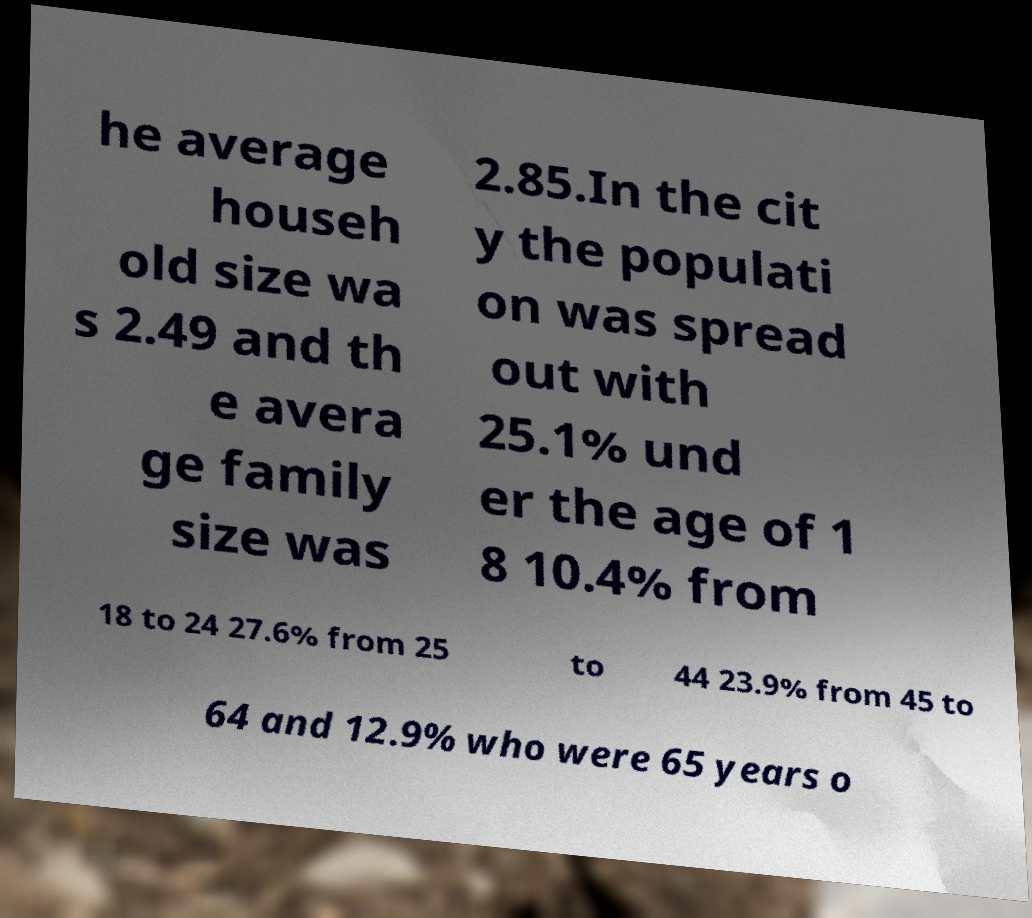For documentation purposes, I need the text within this image transcribed. Could you provide that? he average househ old size wa s 2.49 and th e avera ge family size was 2.85.In the cit y the populati on was spread out with 25.1% und er the age of 1 8 10.4% from 18 to 24 27.6% from 25 to 44 23.9% from 45 to 64 and 12.9% who were 65 years o 